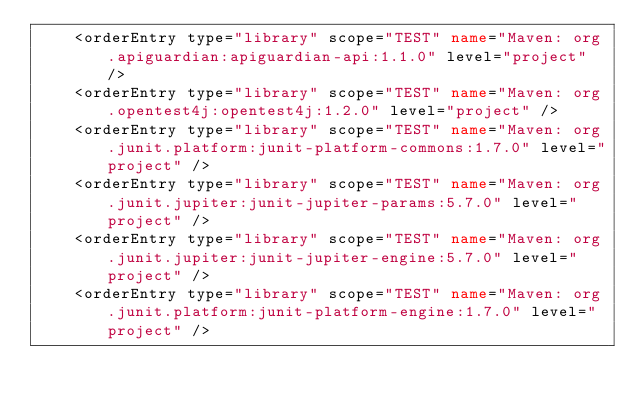<code> <loc_0><loc_0><loc_500><loc_500><_XML_>    <orderEntry type="library" scope="TEST" name="Maven: org.apiguardian:apiguardian-api:1.1.0" level="project" />
    <orderEntry type="library" scope="TEST" name="Maven: org.opentest4j:opentest4j:1.2.0" level="project" />
    <orderEntry type="library" scope="TEST" name="Maven: org.junit.platform:junit-platform-commons:1.7.0" level="project" />
    <orderEntry type="library" scope="TEST" name="Maven: org.junit.jupiter:junit-jupiter-params:5.7.0" level="project" />
    <orderEntry type="library" scope="TEST" name="Maven: org.junit.jupiter:junit-jupiter-engine:5.7.0" level="project" />
    <orderEntry type="library" scope="TEST" name="Maven: org.junit.platform:junit-platform-engine:1.7.0" level="project" /></code> 